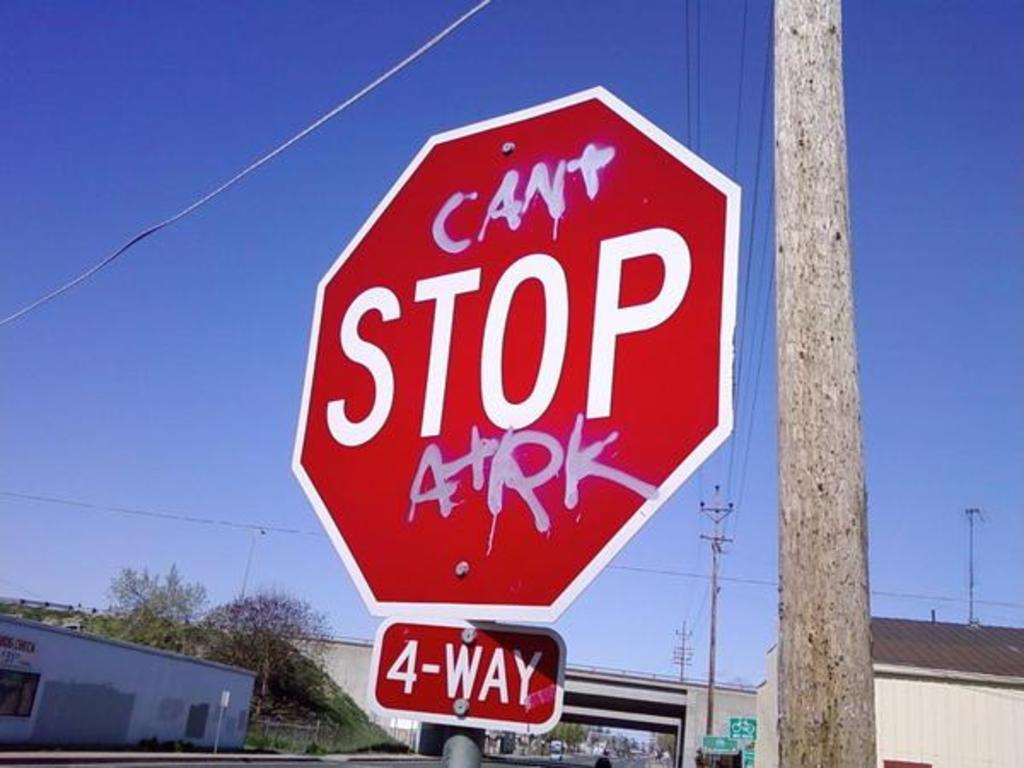<image>
Present a compact description of the photo's key features. red stop sign that read cant stop arrk 